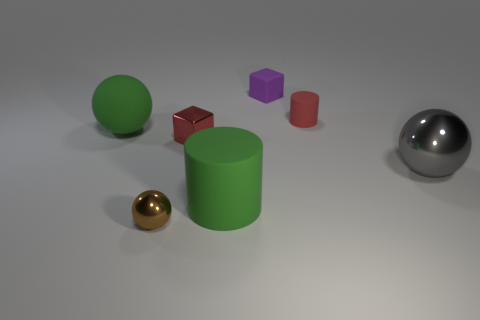Add 3 tiny red rubber objects. How many objects exist? 10 Subtract all cylinders. How many objects are left? 5 Add 2 big rubber cubes. How many big rubber cubes exist? 2 Subtract 0 blue cylinders. How many objects are left? 7 Subtract all big cyan spheres. Subtract all tiny purple objects. How many objects are left? 6 Add 4 matte spheres. How many matte spheres are left? 5 